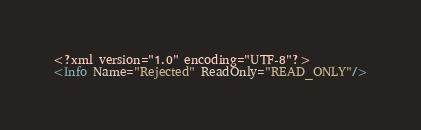Convert code to text. <code><loc_0><loc_0><loc_500><loc_500><_XML_><?xml version="1.0" encoding="UTF-8"?>
<Info Name="Rejected" ReadOnly="READ_ONLY"/>
</code> 